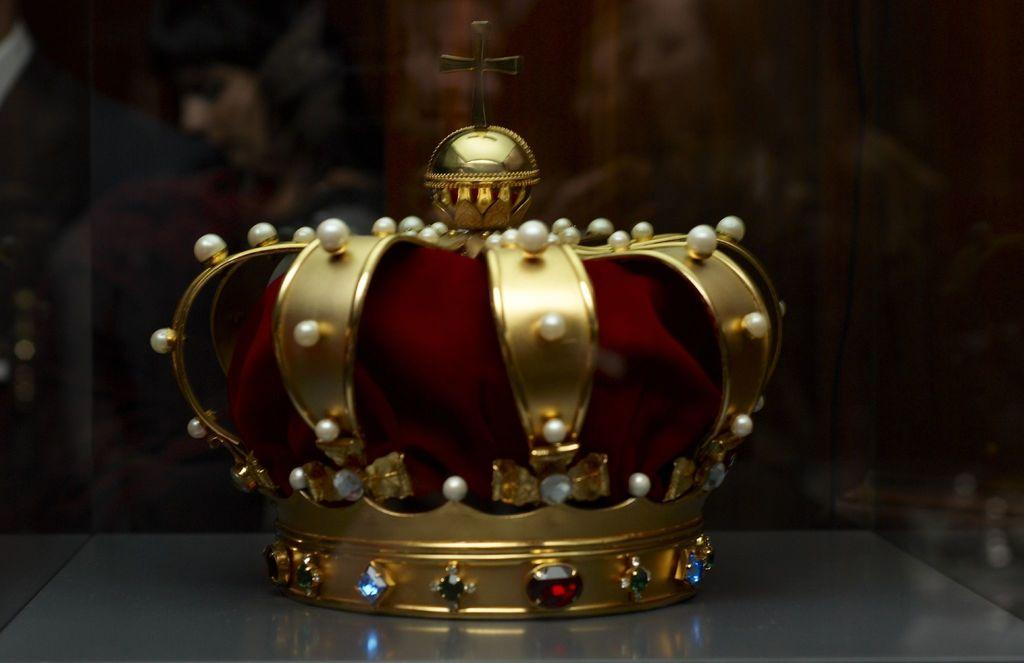What is the main object in the center of the image? There is a crown in the center of the image. What symbol is placed on top of the crown? There is a plus sign on top of the crown. How would you describe the background of the image? The background area is blurred. What is your opinion on the jelly's role in the image? There is no jelly present in the image, so it is not possible to discuss its role or any opinions about it. 